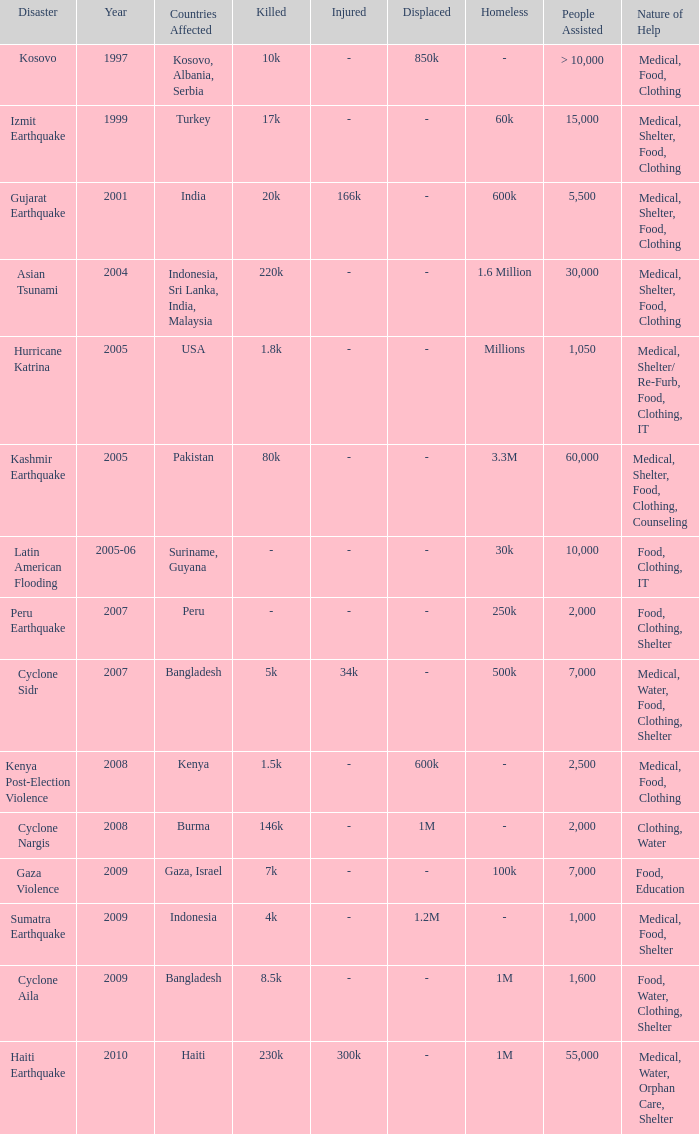How many people were assisted in 1997? > 10,000. 